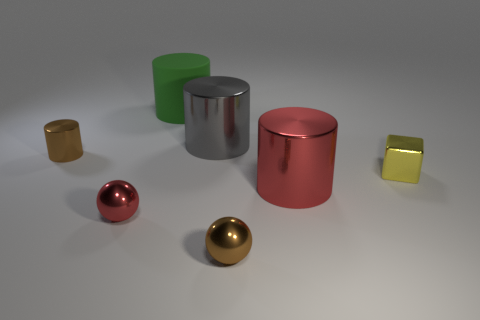Is there anything else that is the same shape as the small yellow thing?
Ensure brevity in your answer.  No. Is there anything else that has the same material as the big green cylinder?
Keep it short and to the point. No. What is the size of the metal ball that is the same color as the small metallic cylinder?
Your response must be concise. Small. Is there another yellow thing made of the same material as the small yellow thing?
Provide a short and direct response. No. What material is the big object that is behind the big gray thing?
Keep it short and to the point. Rubber. What is the material of the big green cylinder?
Your response must be concise. Rubber. Does the cylinder that is in front of the brown cylinder have the same material as the tiny brown sphere?
Give a very brief answer. Yes. Is the number of green objects on the right side of the yellow block less than the number of large green shiny things?
Give a very brief answer. No. What color is the matte cylinder that is the same size as the gray metal thing?
Make the answer very short. Green. What number of blue metallic objects have the same shape as the big matte thing?
Your answer should be very brief. 0. 